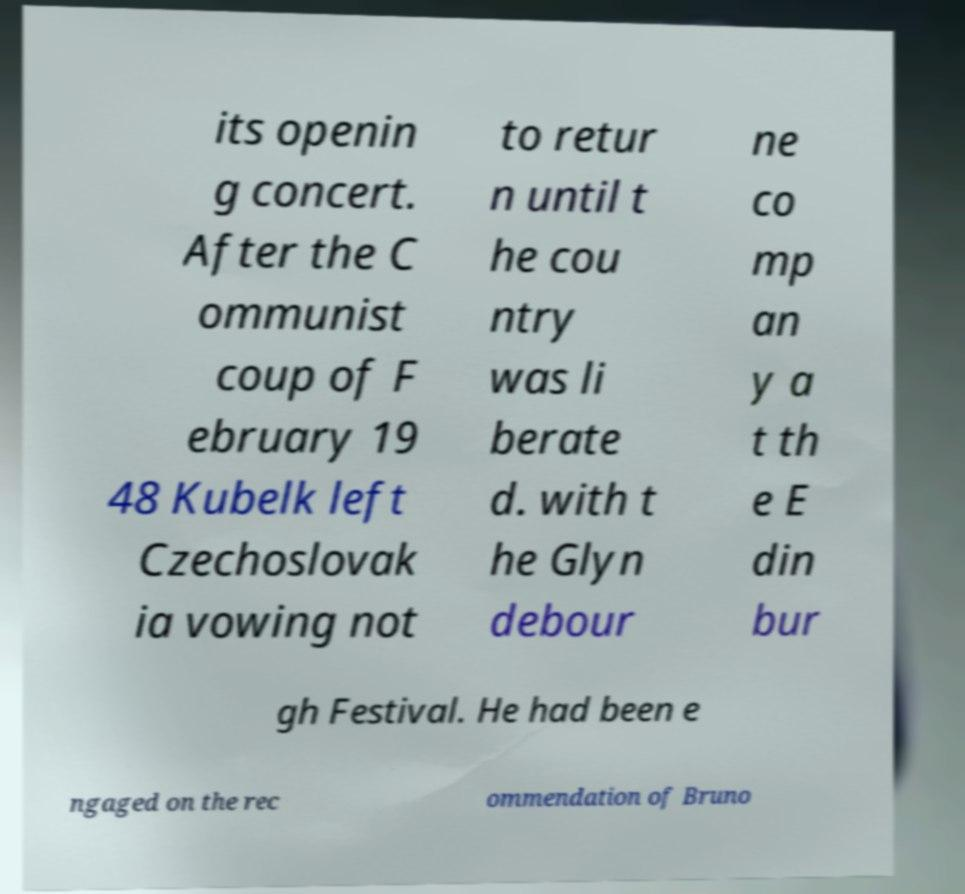Please identify and transcribe the text found in this image. its openin g concert. After the C ommunist coup of F ebruary 19 48 Kubelk left Czechoslovak ia vowing not to retur n until t he cou ntry was li berate d. with t he Glyn debour ne co mp an y a t th e E din bur gh Festival. He had been e ngaged on the rec ommendation of Bruno 